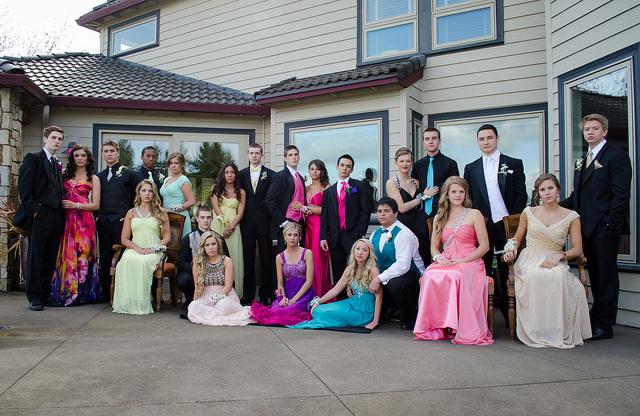Is this photo indoors?
Short answer required. No. What type of wedding dress is this woman wearing?
Quick response, please. White. Where are these kids going?
Short answer required. Prom. Would you call these ties conservative?
Keep it brief. No. Are these people loitering?
Quick response, please. No. How many people have on dresses?
Write a very short answer. 11. Who does the couple resemble?
Short answer required. Prom. What kind of weather it is?
Be succinct. Cloudy. How many people are in pink?
Write a very short answer. 4. What are the people doing?
Write a very short answer. Posing. Is this patterned dress typical for Arabic women?
Keep it brief. No. What is the woman sitting on?
Give a very brief answer. Chair. I see 3 adults?
Concise answer only. No. Who is this man?
Be succinct. Husband. 